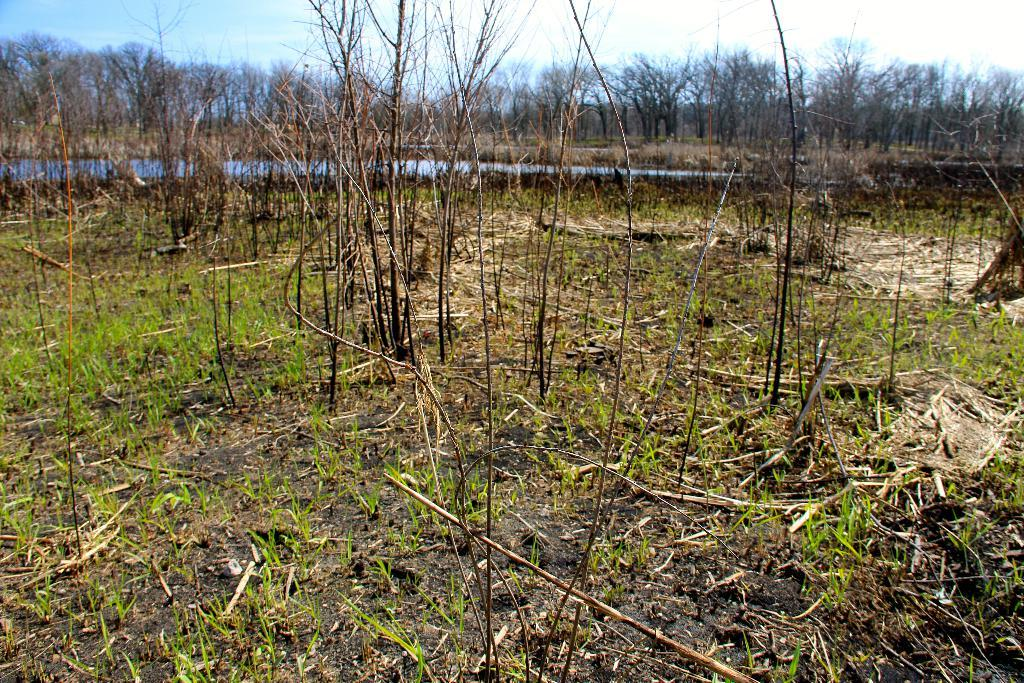What type of vegetation can be seen in the image? There are trees and plants visible in the image. What is on the ground in the image? There are plants on the ground in the image. What can be seen in the background of the image? Water and the sky are visible in the background of the image. Are there any trees in the background? Yes, there are trees in the background of the image. What type of quartz can be seen in the middle of the image? There is no quartz present in the image. How does the loss of the trees affect the ecosystem in the image? The image does not depict any loss of trees, so it is not possible to determine the impact on the ecosystem. 